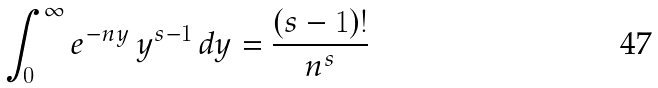Convert formula to latex. <formula><loc_0><loc_0><loc_500><loc_500>\int _ { 0 } ^ { \infty } e ^ { - n y } \, y ^ { s - 1 } \, d y = \frac { ( s - 1 ) ! } { n ^ { s } }</formula> 